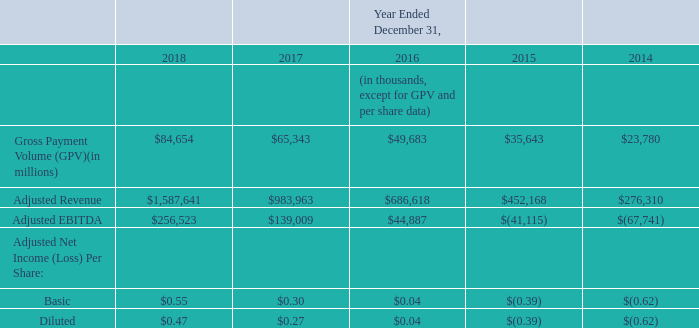Key Operating Metrics and Non-GAAP Financial Measures
We collect and analyze operating and financial data to evaluate the health of our business, allocate our

resources, and assess our performance. In addition to revenue, net loss, and other results under  generally accepted accounting principles (GAAP), the following table sets forth key operating metrics and non-GAAP financial measures we use to evaluate our business. We believe these metrics and measures are useful to facilitate period-to-period comparisons of our business, and to facilitate comparisons of our performance to that of other payment processors. Each of these metrics and measures excludes the effect of our processing agreement with Starbucks which transitioned to another payments solutions provider in the fourth quarter of 2016. As we do not expect transactions with Starbucks to recur, we believe it is useful to exclude Starbucks activity to clearly show the impact Starbucks has had on our financial results historically. Our agreements with other sellers generally provide both those sellers and us the unilateral right to terminate such agreements at any time, without fine or

penalty.
Gross Payment Volume (GPV)
We define GPV as the total dollar amount of all card payments processed by sellers using Square, net of refunds. Additionally, GPV includes Cash App activity related to peer-to-peer payments sent from a credit card and Cash for Business. As described above, GPV excludes card payments processed for Starbucks
Adjusted Revenue
Adjusted Revenue is a non-GAAP financial measure that we define as our total net revenue less transaction-based costs and bitcoin costs, and we add back the impact of the acquired deferred revenue adjustment, which was written down to fair value in purchase. This measure is also adjusted to eliminate the effect of activity with Starbucks, which ceased using our payments solutions altogether in the fourth quarter of 2016, and we believe that providing Adjusted Revenue metrics that exclude the impact of our agreement with Starbucks is useful to investors.
What does GAAP stand for? Generally accepted accounting principles. What is the definition of GPV? Total dollar amount of all card payments processed by sellers using square, net of refunds. What does GPV include? Cash app activity related to peer-to-peer payments sent from a credit card and cash for business. What is the percentage change of GPV from 2017 to 2018?
Answer scale should be: percent. (84,654 - 65,343) / 65,343 
Answer: 29.55. What is the percentage change of Adjusted Revenue from 2016 to 2017?
Answer scale should be: percent. (983,963 - 686,618) / 686,618 
Answer: 43.31. How much is the change of adjusted EBITDA from 2015 to 2016?
Answer scale should be: thousand. 44,887 - (-41,115) 
Answer: 86002. 